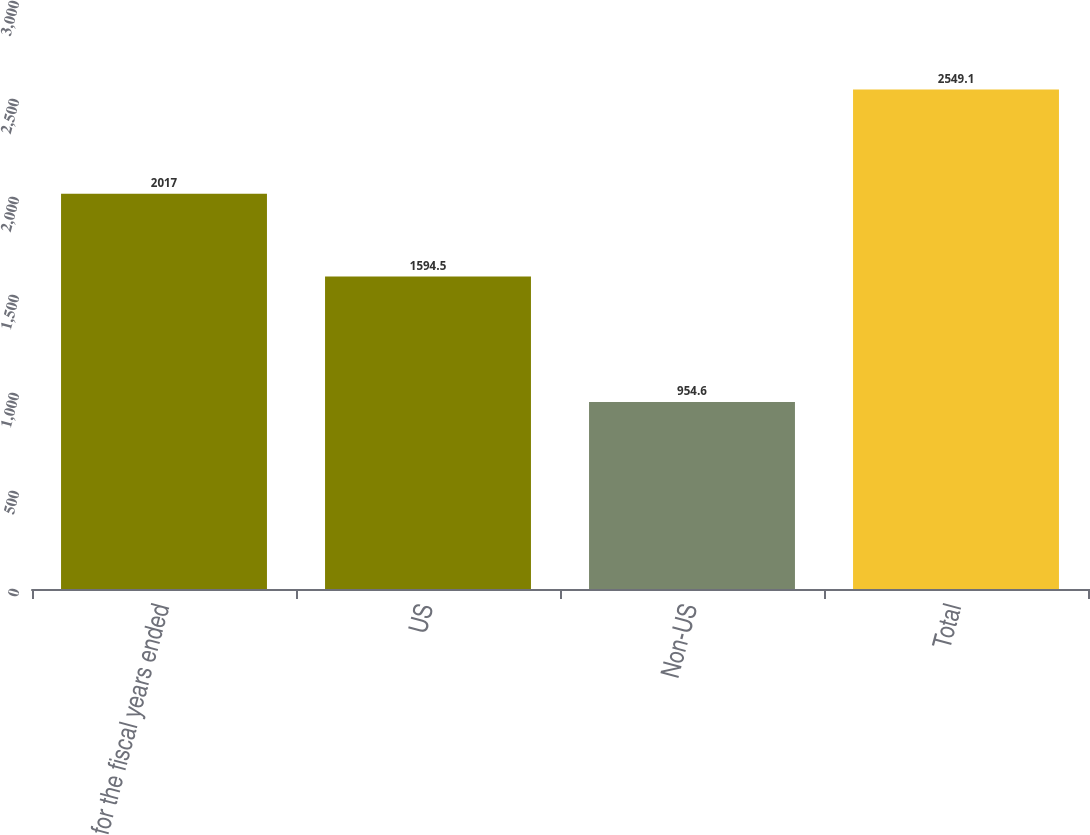<chart> <loc_0><loc_0><loc_500><loc_500><bar_chart><fcel>for the fiscal years ended<fcel>US<fcel>Non-US<fcel>Total<nl><fcel>2017<fcel>1594.5<fcel>954.6<fcel>2549.1<nl></chart> 